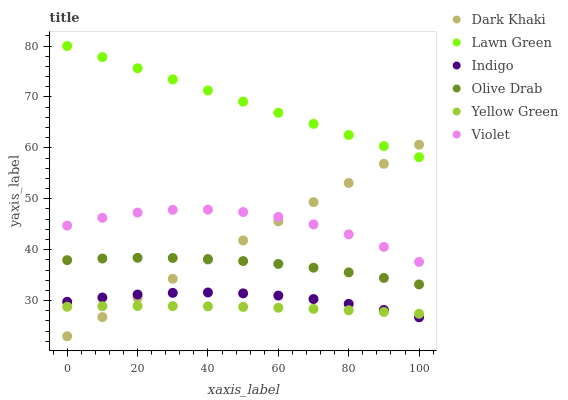Does Yellow Green have the minimum area under the curve?
Answer yes or no. Yes. Does Lawn Green have the maximum area under the curve?
Answer yes or no. Yes. Does Indigo have the minimum area under the curve?
Answer yes or no. No. Does Indigo have the maximum area under the curve?
Answer yes or no. No. Is Dark Khaki the smoothest?
Answer yes or no. Yes. Is Violet the roughest?
Answer yes or no. Yes. Is Indigo the smoothest?
Answer yes or no. No. Is Indigo the roughest?
Answer yes or no. No. Does Dark Khaki have the lowest value?
Answer yes or no. Yes. Does Indigo have the lowest value?
Answer yes or no. No. Does Lawn Green have the highest value?
Answer yes or no. Yes. Does Indigo have the highest value?
Answer yes or no. No. Is Violet less than Lawn Green?
Answer yes or no. Yes. Is Olive Drab greater than Indigo?
Answer yes or no. Yes. Does Olive Drab intersect Dark Khaki?
Answer yes or no. Yes. Is Olive Drab less than Dark Khaki?
Answer yes or no. No. Is Olive Drab greater than Dark Khaki?
Answer yes or no. No. Does Violet intersect Lawn Green?
Answer yes or no. No. 